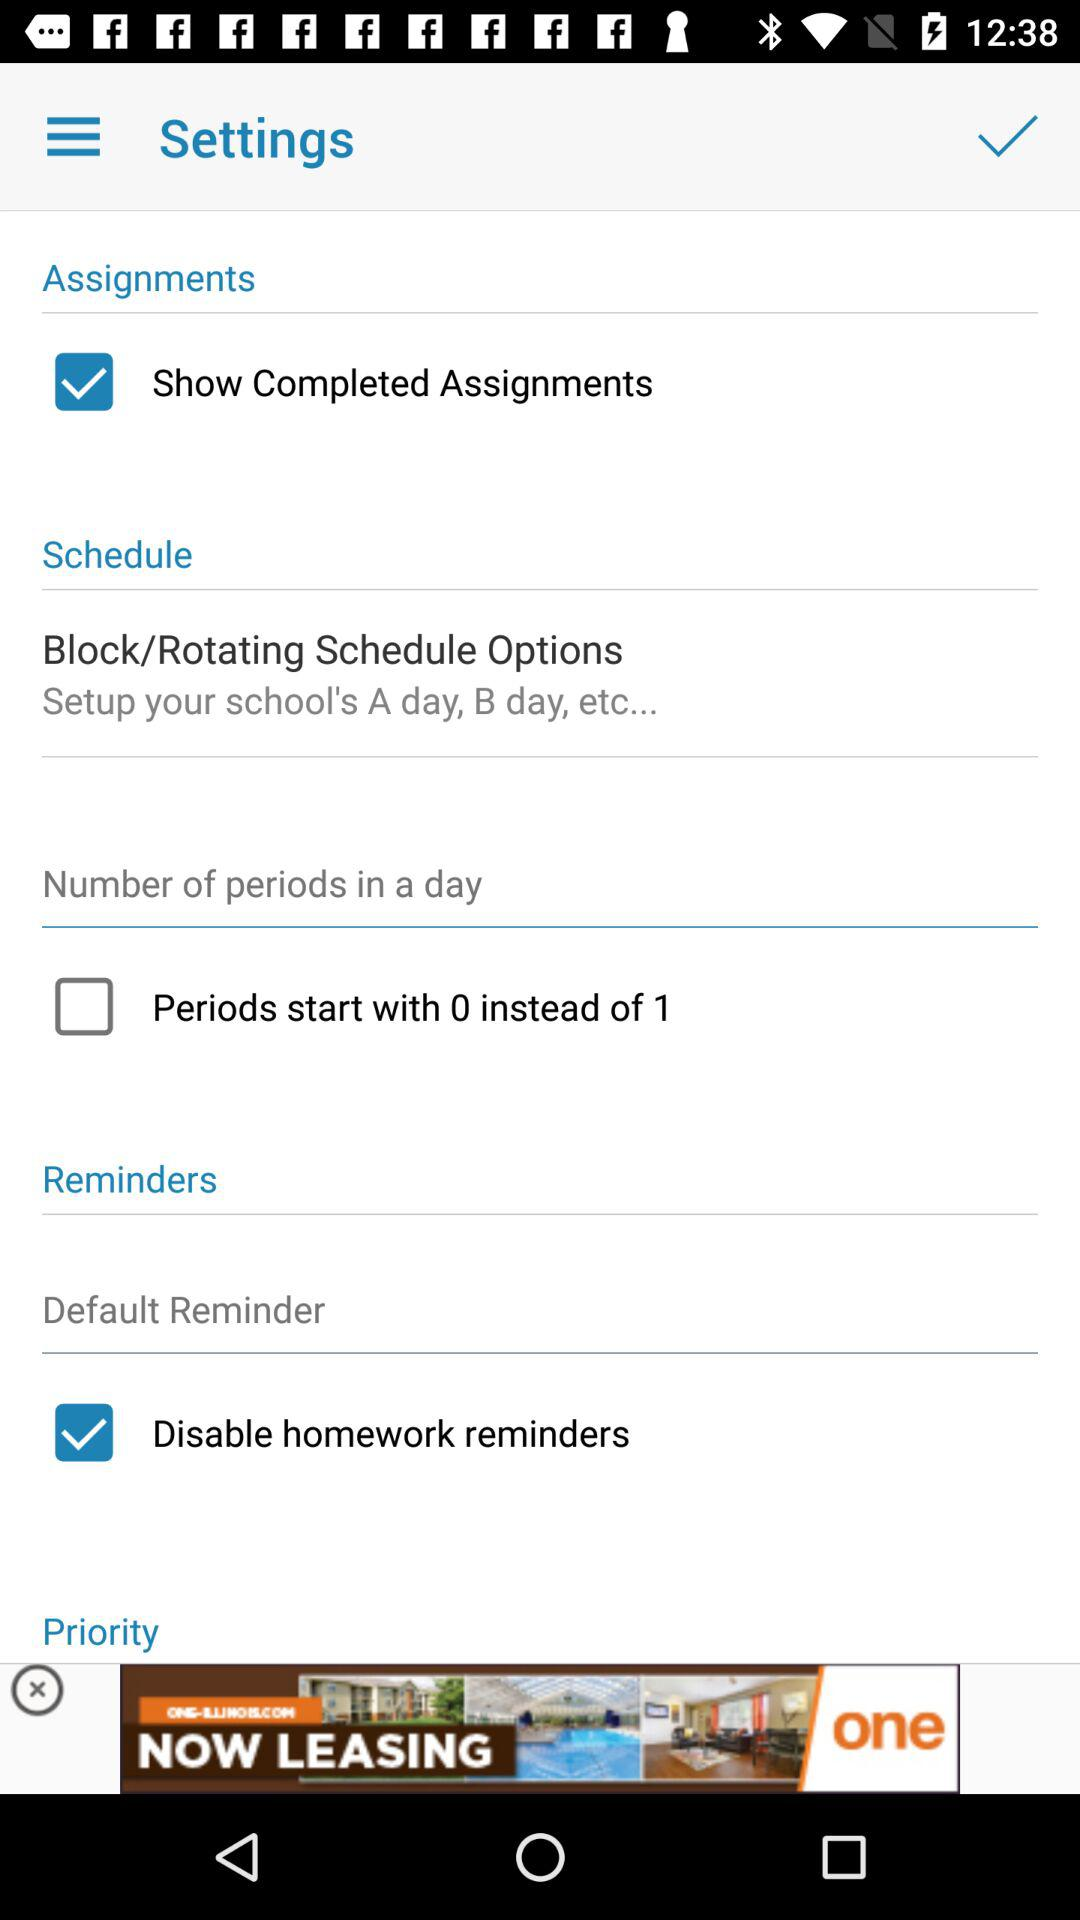What is the status of the "Show Completed Assignments"? The status of "Show Completed Assignments" is "on". 